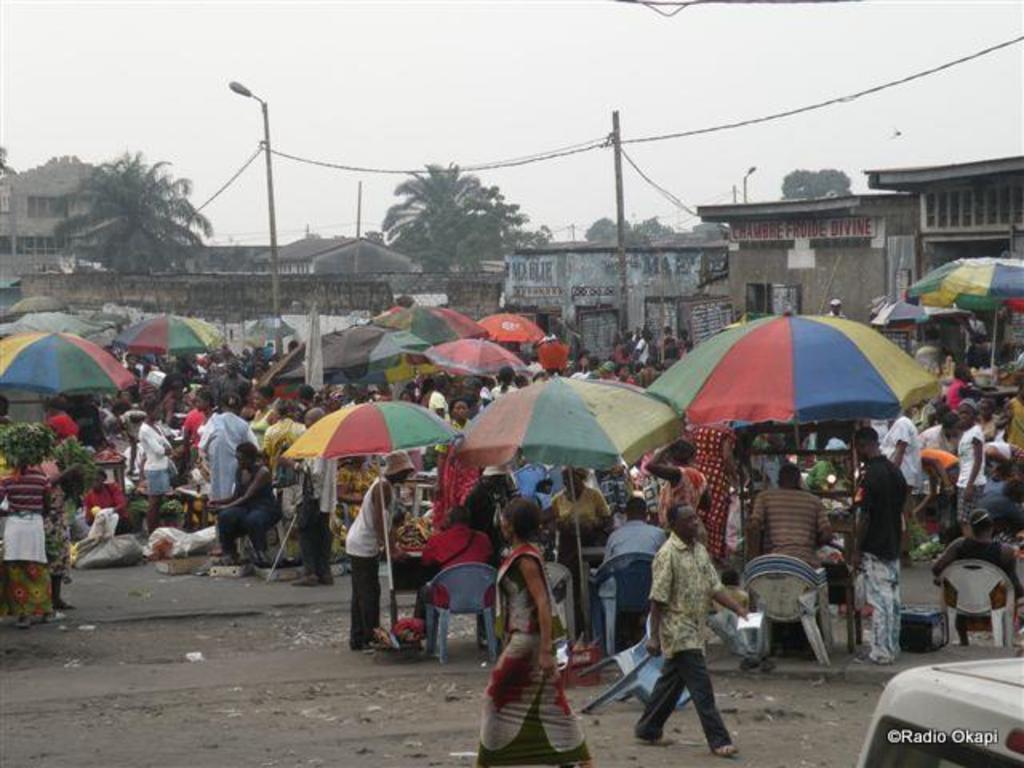Please provide a concise description of this image. In this image we can see few people, among them some people are sitting on the chairs, there are some buildings, trees, umbrellas, poles, wires, lights, vegetables and some other objects on the ground, also we can see the wall and in the background we can see the sky. 